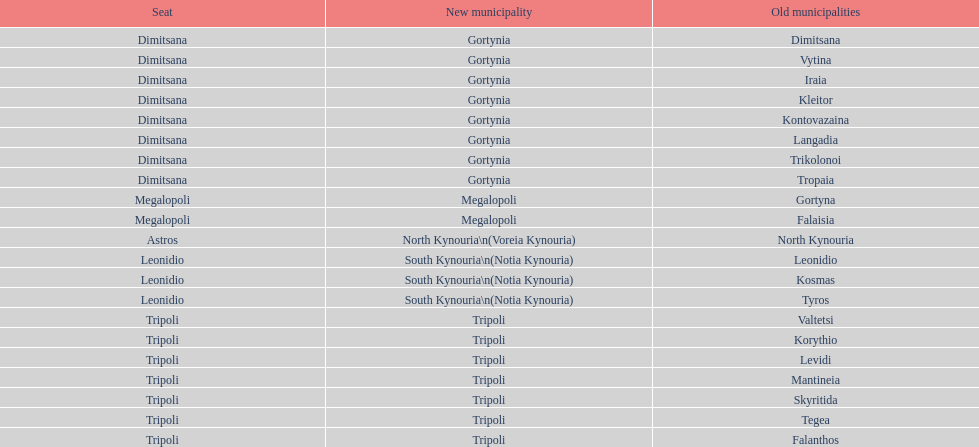What is the new municipality of tyros? South Kynouria. 